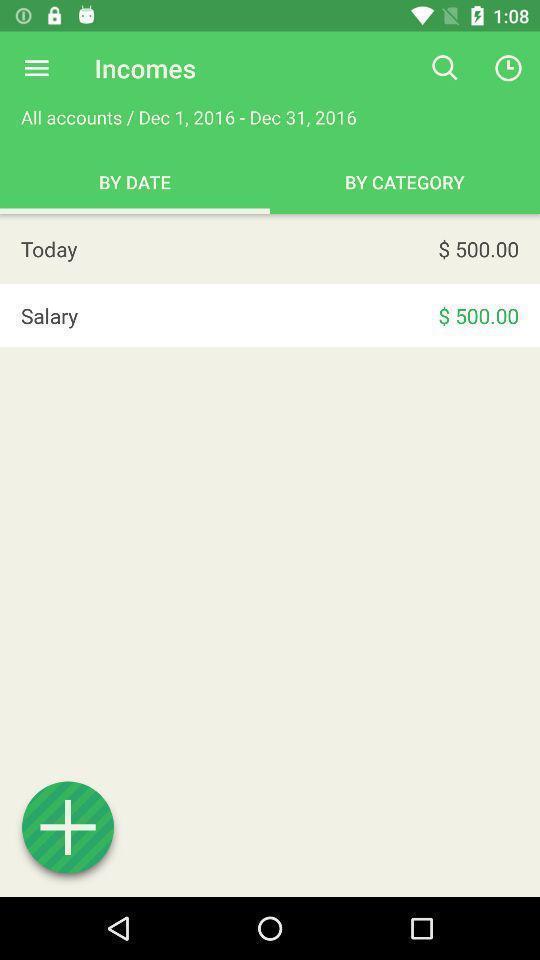Provide a detailed account of this screenshot. Screen page of a financial app. 